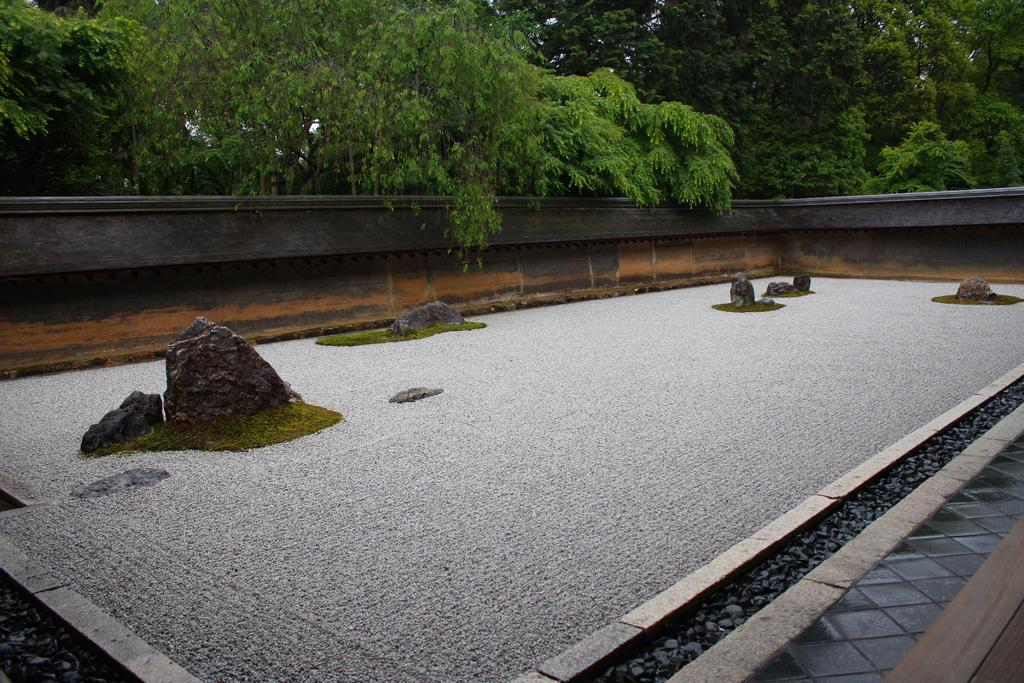What part of a building is visible in the image? The image shows the roof of a building. What materials can be seen on the roof? There are stones and a carpet on the roof. What can be seen in the distance from the roof? Trees are visible from the roof. What type of shelf can be seen on the roof in the image? There is no shelf present on the roof in the image. 